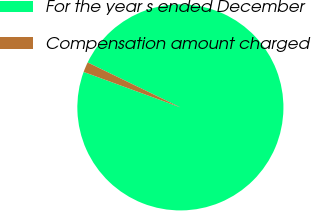Convert chart. <chart><loc_0><loc_0><loc_500><loc_500><pie_chart><fcel>For the year s ended December<fcel>Compensation amount charged<nl><fcel>98.41%<fcel>1.59%<nl></chart> 